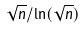<formula> <loc_0><loc_0><loc_500><loc_500>\sqrt { n } / \ln ( \sqrt { n } )</formula> 